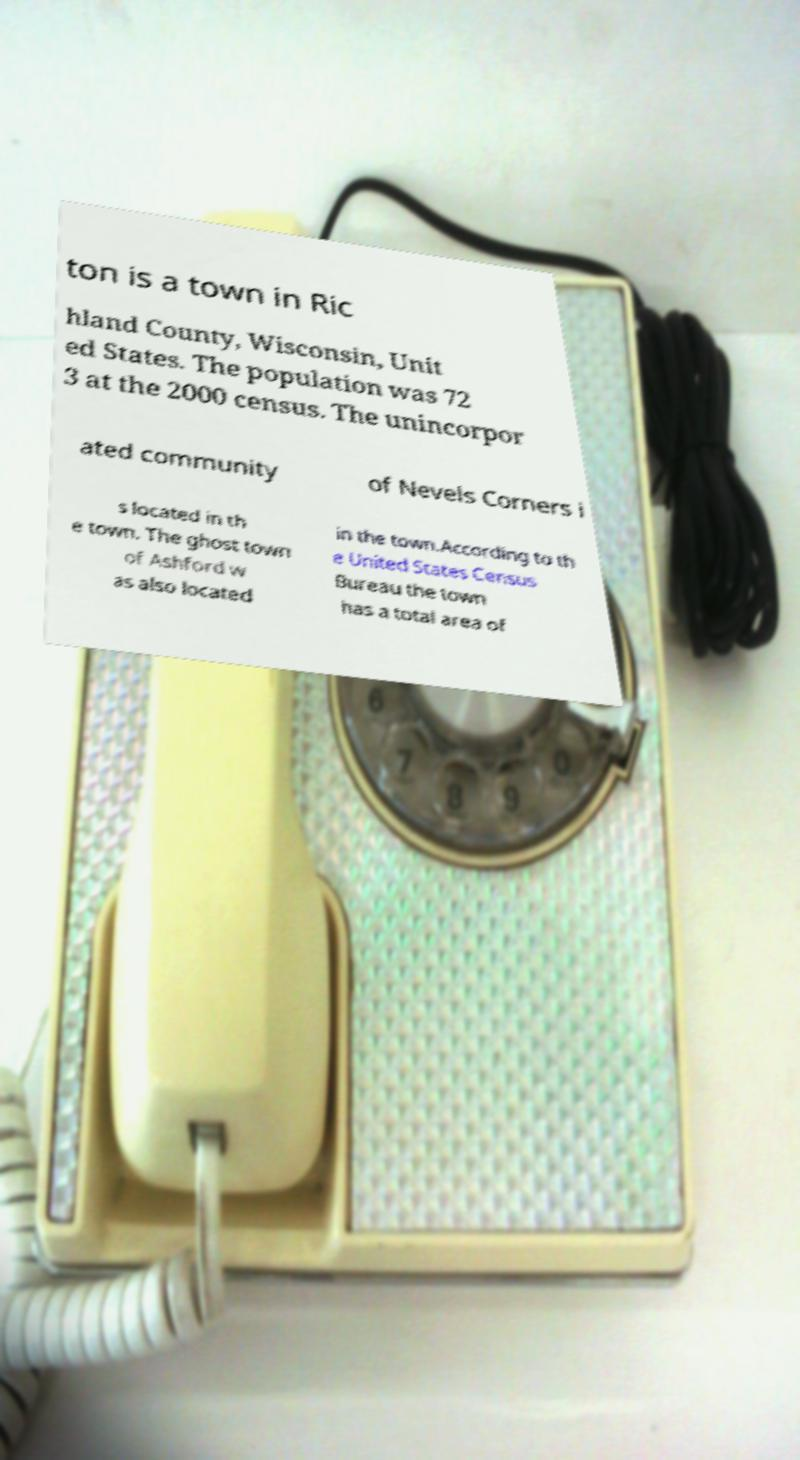Can you read and provide the text displayed in the image?This photo seems to have some interesting text. Can you extract and type it out for me? ton is a town in Ric hland County, Wisconsin, Unit ed States. The population was 72 3 at the 2000 census. The unincorpor ated community of Nevels Corners i s located in th e town. The ghost town of Ashford w as also located in the town.According to th e United States Census Bureau the town has a total area of 